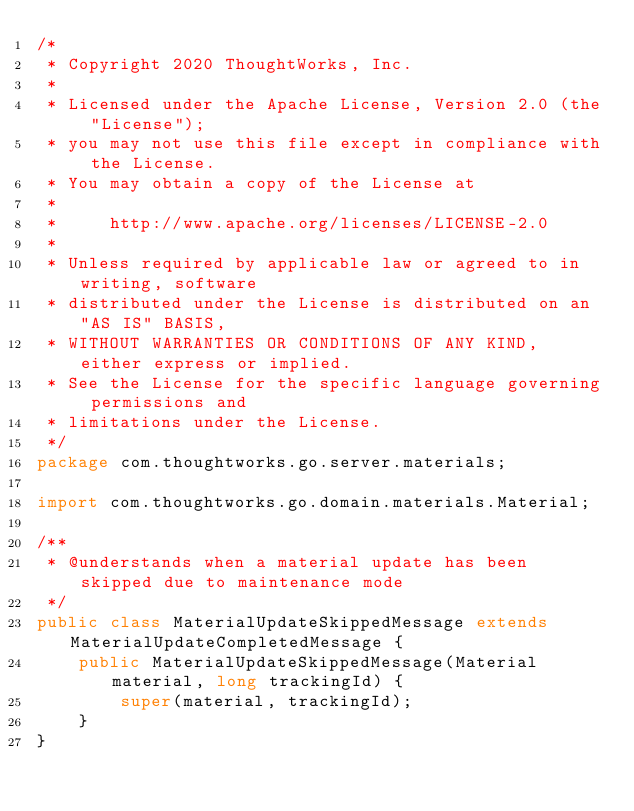<code> <loc_0><loc_0><loc_500><loc_500><_Java_>/*
 * Copyright 2020 ThoughtWorks, Inc.
 *
 * Licensed under the Apache License, Version 2.0 (the "License");
 * you may not use this file except in compliance with the License.
 * You may obtain a copy of the License at
 *
 *     http://www.apache.org/licenses/LICENSE-2.0
 *
 * Unless required by applicable law or agreed to in writing, software
 * distributed under the License is distributed on an "AS IS" BASIS,
 * WITHOUT WARRANTIES OR CONDITIONS OF ANY KIND, either express or implied.
 * See the License for the specific language governing permissions and
 * limitations under the License.
 */
package com.thoughtworks.go.server.materials;

import com.thoughtworks.go.domain.materials.Material;

/**
 * @understands when a material update has been skipped due to maintenance mode
 */
public class MaterialUpdateSkippedMessage extends MaterialUpdateCompletedMessage {
    public MaterialUpdateSkippedMessage(Material material, long trackingId) {
        super(material, trackingId);
    }
}
</code> 